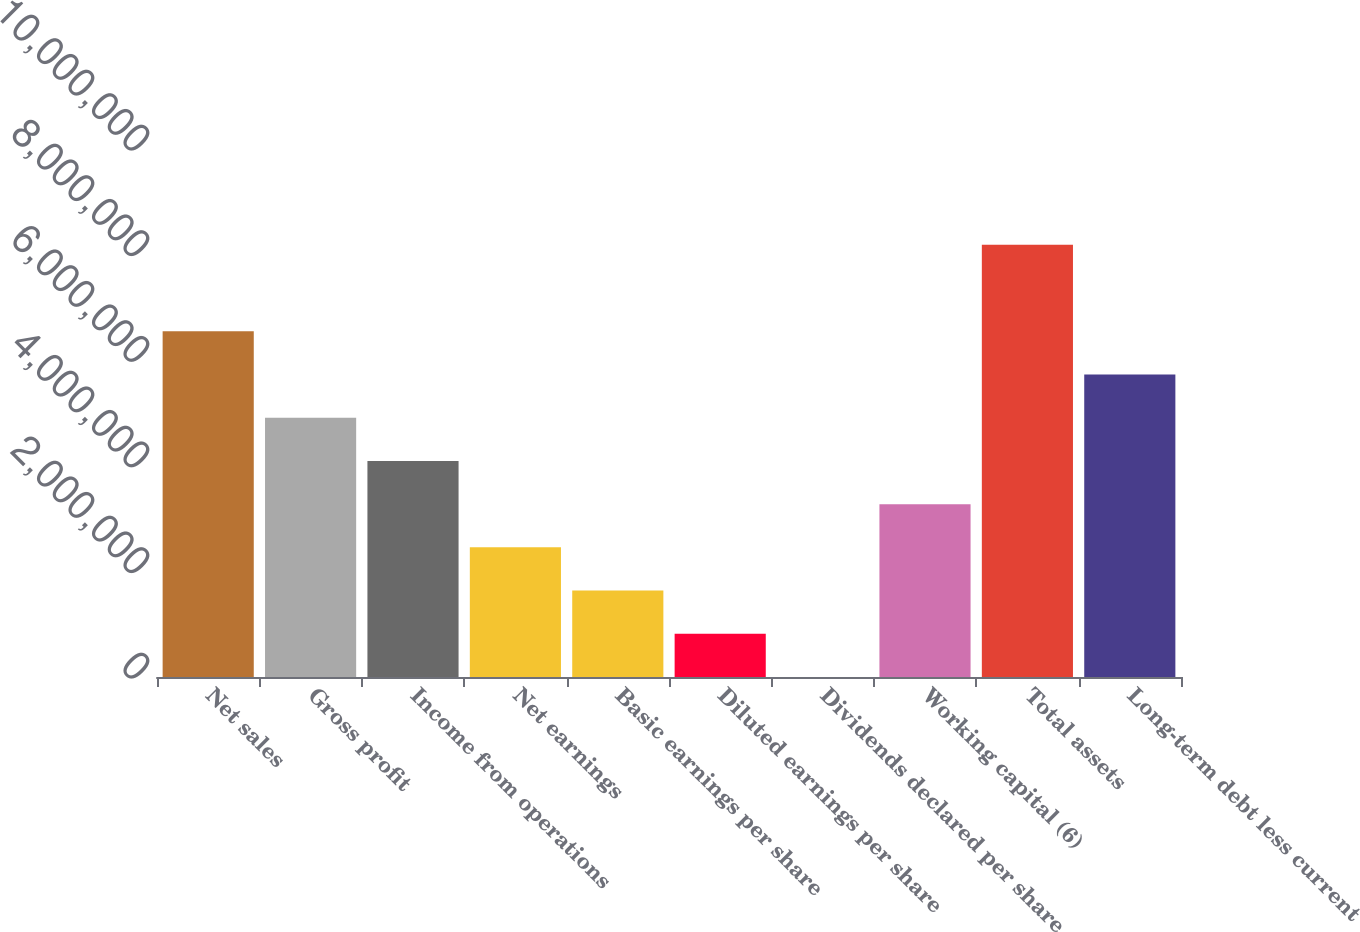Convert chart to OTSL. <chart><loc_0><loc_0><loc_500><loc_500><bar_chart><fcel>Net sales<fcel>Gross profit<fcel>Income from operations<fcel>Net earnings<fcel>Basic earnings per share<fcel>Diluted earnings per share<fcel>Dividends declared per share<fcel>Working capital (6)<fcel>Total assets<fcel>Long-term debt less current<nl><fcel>6.54798e+06<fcel>4.91099e+06<fcel>4.09249e+06<fcel>2.45549e+06<fcel>1.637e+06<fcel>818499<fcel>0.69<fcel>3.27399e+06<fcel>8.18498e+06<fcel>5.72949e+06<nl></chart> 